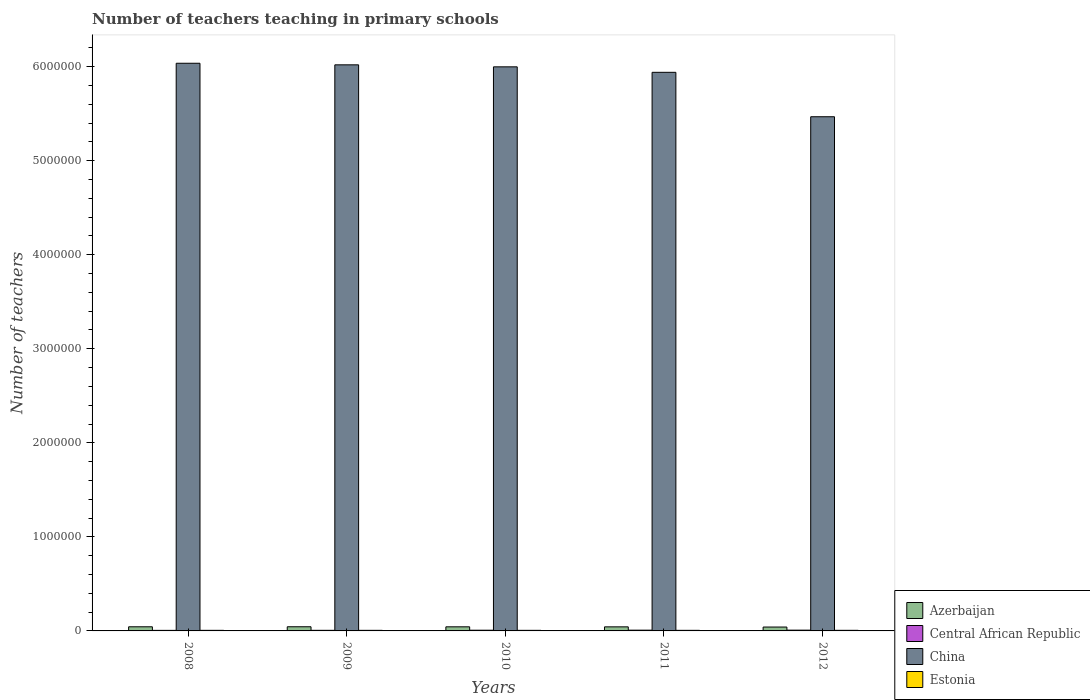How many different coloured bars are there?
Give a very brief answer. 4. How many groups of bars are there?
Ensure brevity in your answer.  5. Are the number of bars per tick equal to the number of legend labels?
Your answer should be compact. Yes. Are the number of bars on each tick of the X-axis equal?
Your answer should be very brief. Yes. How many bars are there on the 5th tick from the left?
Provide a succinct answer. 4. How many bars are there on the 5th tick from the right?
Offer a terse response. 4. In how many cases, is the number of bars for a given year not equal to the number of legend labels?
Your answer should be compact. 0. What is the number of teachers teaching in primary schools in Central African Republic in 2008?
Your response must be concise. 5827. Across all years, what is the maximum number of teachers teaching in primary schools in Azerbaijan?
Make the answer very short. 4.42e+04. Across all years, what is the minimum number of teachers teaching in primary schools in Central African Republic?
Your response must be concise. 5827. What is the total number of teachers teaching in primary schools in Central African Republic in the graph?
Offer a very short reply. 3.60e+04. What is the difference between the number of teachers teaching in primary schools in Estonia in 2009 and that in 2011?
Give a very brief answer. -17. What is the difference between the number of teachers teaching in primary schools in Central African Republic in 2010 and the number of teachers teaching in primary schools in China in 2012?
Provide a short and direct response. -5.46e+06. What is the average number of teachers teaching in primary schools in Azerbaijan per year?
Ensure brevity in your answer.  4.33e+04. In the year 2008, what is the difference between the number of teachers teaching in primary schools in Estonia and number of teachers teaching in primary schools in China?
Give a very brief answer. -6.03e+06. What is the ratio of the number of teachers teaching in primary schools in Central African Republic in 2009 to that in 2012?
Offer a very short reply. 0.78. Is the number of teachers teaching in primary schools in Azerbaijan in 2010 less than that in 2012?
Make the answer very short. No. What is the difference between the highest and the second highest number of teachers teaching in primary schools in Central African Republic?
Offer a very short reply. 293. What is the difference between the highest and the lowest number of teachers teaching in primary schools in China?
Your answer should be compact. 5.69e+05. In how many years, is the number of teachers teaching in primary schools in Estonia greater than the average number of teachers teaching in primary schools in Estonia taken over all years?
Offer a terse response. 1. Is the sum of the number of teachers teaching in primary schools in China in 2008 and 2009 greater than the maximum number of teachers teaching in primary schools in Central African Republic across all years?
Your answer should be very brief. Yes. What does the 4th bar from the left in 2009 represents?
Your response must be concise. Estonia. What does the 2nd bar from the right in 2010 represents?
Offer a very short reply. China. Is it the case that in every year, the sum of the number of teachers teaching in primary schools in Azerbaijan and number of teachers teaching in primary schools in Estonia is greater than the number of teachers teaching in primary schools in Central African Republic?
Ensure brevity in your answer.  Yes. How many bars are there?
Keep it short and to the point. 20. How many years are there in the graph?
Offer a very short reply. 5. Does the graph contain grids?
Give a very brief answer. No. Where does the legend appear in the graph?
Keep it short and to the point. Bottom right. How many legend labels are there?
Your answer should be very brief. 4. How are the legend labels stacked?
Keep it short and to the point. Vertical. What is the title of the graph?
Your answer should be very brief. Number of teachers teaching in primary schools. What is the label or title of the Y-axis?
Your answer should be compact. Number of teachers. What is the Number of teachers of Azerbaijan in 2008?
Your answer should be compact. 4.40e+04. What is the Number of teachers of Central African Republic in 2008?
Keep it short and to the point. 5827. What is the Number of teachers of China in 2008?
Make the answer very short. 6.04e+06. What is the Number of teachers of Estonia in 2008?
Keep it short and to the point. 6141. What is the Number of teachers in Azerbaijan in 2009?
Keep it short and to the point. 4.42e+04. What is the Number of teachers of Central African Republic in 2009?
Your answer should be compact. 6427. What is the Number of teachers in China in 2009?
Give a very brief answer. 6.02e+06. What is the Number of teachers of Estonia in 2009?
Your answer should be very brief. 6183. What is the Number of teachers in Azerbaijan in 2010?
Your answer should be compact. 4.36e+04. What is the Number of teachers in Central African Republic in 2010?
Give a very brief answer. 7553. What is the Number of teachers in China in 2010?
Make the answer very short. 6.00e+06. What is the Number of teachers of Estonia in 2010?
Provide a short and direct response. 6223. What is the Number of teachers in Azerbaijan in 2011?
Provide a succinct answer. 4.32e+04. What is the Number of teachers of Central African Republic in 2011?
Make the answer very short. 7974. What is the Number of teachers of China in 2011?
Your answer should be compact. 5.94e+06. What is the Number of teachers in Estonia in 2011?
Provide a succinct answer. 6200. What is the Number of teachers in Azerbaijan in 2012?
Ensure brevity in your answer.  4.12e+04. What is the Number of teachers in Central African Republic in 2012?
Make the answer very short. 8267. What is the Number of teachers in China in 2012?
Make the answer very short. 5.47e+06. What is the Number of teachers in Estonia in 2012?
Offer a terse response. 6431. Across all years, what is the maximum Number of teachers of Azerbaijan?
Give a very brief answer. 4.42e+04. Across all years, what is the maximum Number of teachers of Central African Republic?
Make the answer very short. 8267. Across all years, what is the maximum Number of teachers in China?
Give a very brief answer. 6.04e+06. Across all years, what is the maximum Number of teachers in Estonia?
Offer a very short reply. 6431. Across all years, what is the minimum Number of teachers in Azerbaijan?
Ensure brevity in your answer.  4.12e+04. Across all years, what is the minimum Number of teachers in Central African Republic?
Offer a terse response. 5827. Across all years, what is the minimum Number of teachers of China?
Give a very brief answer. 5.47e+06. Across all years, what is the minimum Number of teachers in Estonia?
Give a very brief answer. 6141. What is the total Number of teachers of Azerbaijan in the graph?
Give a very brief answer. 2.16e+05. What is the total Number of teachers of Central African Republic in the graph?
Make the answer very short. 3.60e+04. What is the total Number of teachers in China in the graph?
Your answer should be compact. 2.95e+07. What is the total Number of teachers in Estonia in the graph?
Make the answer very short. 3.12e+04. What is the difference between the Number of teachers of Azerbaijan in 2008 and that in 2009?
Your answer should be very brief. -261. What is the difference between the Number of teachers in Central African Republic in 2008 and that in 2009?
Ensure brevity in your answer.  -600. What is the difference between the Number of teachers of China in 2008 and that in 2009?
Provide a short and direct response. 1.67e+04. What is the difference between the Number of teachers of Estonia in 2008 and that in 2009?
Keep it short and to the point. -42. What is the difference between the Number of teachers in Azerbaijan in 2008 and that in 2010?
Provide a short and direct response. 361. What is the difference between the Number of teachers of Central African Republic in 2008 and that in 2010?
Give a very brief answer. -1726. What is the difference between the Number of teachers of China in 2008 and that in 2010?
Provide a short and direct response. 3.81e+04. What is the difference between the Number of teachers of Estonia in 2008 and that in 2010?
Keep it short and to the point. -82. What is the difference between the Number of teachers of Azerbaijan in 2008 and that in 2011?
Ensure brevity in your answer.  729. What is the difference between the Number of teachers in Central African Republic in 2008 and that in 2011?
Provide a short and direct response. -2147. What is the difference between the Number of teachers of China in 2008 and that in 2011?
Offer a very short reply. 9.64e+04. What is the difference between the Number of teachers of Estonia in 2008 and that in 2011?
Your answer should be very brief. -59. What is the difference between the Number of teachers of Azerbaijan in 2008 and that in 2012?
Provide a succinct answer. 2750. What is the difference between the Number of teachers in Central African Republic in 2008 and that in 2012?
Your answer should be compact. -2440. What is the difference between the Number of teachers in China in 2008 and that in 2012?
Your answer should be very brief. 5.69e+05. What is the difference between the Number of teachers of Estonia in 2008 and that in 2012?
Make the answer very short. -290. What is the difference between the Number of teachers of Azerbaijan in 2009 and that in 2010?
Ensure brevity in your answer.  622. What is the difference between the Number of teachers in Central African Republic in 2009 and that in 2010?
Provide a succinct answer. -1126. What is the difference between the Number of teachers of China in 2009 and that in 2010?
Offer a very short reply. 2.14e+04. What is the difference between the Number of teachers in Estonia in 2009 and that in 2010?
Provide a short and direct response. -40. What is the difference between the Number of teachers in Azerbaijan in 2009 and that in 2011?
Provide a short and direct response. 990. What is the difference between the Number of teachers in Central African Republic in 2009 and that in 2011?
Keep it short and to the point. -1547. What is the difference between the Number of teachers of China in 2009 and that in 2011?
Your response must be concise. 7.97e+04. What is the difference between the Number of teachers in Estonia in 2009 and that in 2011?
Provide a succinct answer. -17. What is the difference between the Number of teachers in Azerbaijan in 2009 and that in 2012?
Offer a terse response. 3011. What is the difference between the Number of teachers in Central African Republic in 2009 and that in 2012?
Offer a very short reply. -1840. What is the difference between the Number of teachers of China in 2009 and that in 2012?
Offer a very short reply. 5.52e+05. What is the difference between the Number of teachers of Estonia in 2009 and that in 2012?
Ensure brevity in your answer.  -248. What is the difference between the Number of teachers of Azerbaijan in 2010 and that in 2011?
Offer a very short reply. 368. What is the difference between the Number of teachers in Central African Republic in 2010 and that in 2011?
Ensure brevity in your answer.  -421. What is the difference between the Number of teachers of China in 2010 and that in 2011?
Give a very brief answer. 5.83e+04. What is the difference between the Number of teachers of Azerbaijan in 2010 and that in 2012?
Your response must be concise. 2389. What is the difference between the Number of teachers in Central African Republic in 2010 and that in 2012?
Provide a short and direct response. -714. What is the difference between the Number of teachers in China in 2010 and that in 2012?
Provide a succinct answer. 5.30e+05. What is the difference between the Number of teachers in Estonia in 2010 and that in 2012?
Your response must be concise. -208. What is the difference between the Number of teachers of Azerbaijan in 2011 and that in 2012?
Keep it short and to the point. 2021. What is the difference between the Number of teachers in Central African Republic in 2011 and that in 2012?
Provide a short and direct response. -293. What is the difference between the Number of teachers of China in 2011 and that in 2012?
Offer a terse response. 4.72e+05. What is the difference between the Number of teachers in Estonia in 2011 and that in 2012?
Make the answer very short. -231. What is the difference between the Number of teachers of Azerbaijan in 2008 and the Number of teachers of Central African Republic in 2009?
Your response must be concise. 3.75e+04. What is the difference between the Number of teachers in Azerbaijan in 2008 and the Number of teachers in China in 2009?
Your answer should be very brief. -5.97e+06. What is the difference between the Number of teachers of Azerbaijan in 2008 and the Number of teachers of Estonia in 2009?
Your answer should be very brief. 3.78e+04. What is the difference between the Number of teachers in Central African Republic in 2008 and the Number of teachers in China in 2009?
Ensure brevity in your answer.  -6.01e+06. What is the difference between the Number of teachers in Central African Republic in 2008 and the Number of teachers in Estonia in 2009?
Ensure brevity in your answer.  -356. What is the difference between the Number of teachers in China in 2008 and the Number of teachers in Estonia in 2009?
Provide a short and direct response. 6.03e+06. What is the difference between the Number of teachers of Azerbaijan in 2008 and the Number of teachers of Central African Republic in 2010?
Make the answer very short. 3.64e+04. What is the difference between the Number of teachers in Azerbaijan in 2008 and the Number of teachers in China in 2010?
Offer a terse response. -5.95e+06. What is the difference between the Number of teachers in Azerbaijan in 2008 and the Number of teachers in Estonia in 2010?
Offer a terse response. 3.77e+04. What is the difference between the Number of teachers in Central African Republic in 2008 and the Number of teachers in China in 2010?
Keep it short and to the point. -5.99e+06. What is the difference between the Number of teachers in Central African Republic in 2008 and the Number of teachers in Estonia in 2010?
Make the answer very short. -396. What is the difference between the Number of teachers of China in 2008 and the Number of teachers of Estonia in 2010?
Give a very brief answer. 6.03e+06. What is the difference between the Number of teachers of Azerbaijan in 2008 and the Number of teachers of Central African Republic in 2011?
Provide a short and direct response. 3.60e+04. What is the difference between the Number of teachers in Azerbaijan in 2008 and the Number of teachers in China in 2011?
Provide a short and direct response. -5.90e+06. What is the difference between the Number of teachers of Azerbaijan in 2008 and the Number of teachers of Estonia in 2011?
Your response must be concise. 3.78e+04. What is the difference between the Number of teachers in Central African Republic in 2008 and the Number of teachers in China in 2011?
Make the answer very short. -5.93e+06. What is the difference between the Number of teachers of Central African Republic in 2008 and the Number of teachers of Estonia in 2011?
Offer a terse response. -373. What is the difference between the Number of teachers in China in 2008 and the Number of teachers in Estonia in 2011?
Offer a terse response. 6.03e+06. What is the difference between the Number of teachers of Azerbaijan in 2008 and the Number of teachers of Central African Republic in 2012?
Keep it short and to the point. 3.57e+04. What is the difference between the Number of teachers of Azerbaijan in 2008 and the Number of teachers of China in 2012?
Keep it short and to the point. -5.42e+06. What is the difference between the Number of teachers of Azerbaijan in 2008 and the Number of teachers of Estonia in 2012?
Keep it short and to the point. 3.75e+04. What is the difference between the Number of teachers of Central African Republic in 2008 and the Number of teachers of China in 2012?
Offer a terse response. -5.46e+06. What is the difference between the Number of teachers in Central African Republic in 2008 and the Number of teachers in Estonia in 2012?
Provide a short and direct response. -604. What is the difference between the Number of teachers of China in 2008 and the Number of teachers of Estonia in 2012?
Your answer should be compact. 6.03e+06. What is the difference between the Number of teachers of Azerbaijan in 2009 and the Number of teachers of Central African Republic in 2010?
Your response must be concise. 3.67e+04. What is the difference between the Number of teachers in Azerbaijan in 2009 and the Number of teachers in China in 2010?
Provide a short and direct response. -5.95e+06. What is the difference between the Number of teachers in Azerbaijan in 2009 and the Number of teachers in Estonia in 2010?
Offer a very short reply. 3.80e+04. What is the difference between the Number of teachers in Central African Republic in 2009 and the Number of teachers in China in 2010?
Give a very brief answer. -5.99e+06. What is the difference between the Number of teachers in Central African Republic in 2009 and the Number of teachers in Estonia in 2010?
Your answer should be compact. 204. What is the difference between the Number of teachers in China in 2009 and the Number of teachers in Estonia in 2010?
Provide a short and direct response. 6.01e+06. What is the difference between the Number of teachers in Azerbaijan in 2009 and the Number of teachers in Central African Republic in 2011?
Give a very brief answer. 3.63e+04. What is the difference between the Number of teachers of Azerbaijan in 2009 and the Number of teachers of China in 2011?
Keep it short and to the point. -5.89e+06. What is the difference between the Number of teachers in Azerbaijan in 2009 and the Number of teachers in Estonia in 2011?
Provide a short and direct response. 3.80e+04. What is the difference between the Number of teachers in Central African Republic in 2009 and the Number of teachers in China in 2011?
Keep it short and to the point. -5.93e+06. What is the difference between the Number of teachers of Central African Republic in 2009 and the Number of teachers of Estonia in 2011?
Your response must be concise. 227. What is the difference between the Number of teachers of China in 2009 and the Number of teachers of Estonia in 2011?
Make the answer very short. 6.01e+06. What is the difference between the Number of teachers in Azerbaijan in 2009 and the Number of teachers in Central African Republic in 2012?
Give a very brief answer. 3.60e+04. What is the difference between the Number of teachers in Azerbaijan in 2009 and the Number of teachers in China in 2012?
Ensure brevity in your answer.  -5.42e+06. What is the difference between the Number of teachers in Azerbaijan in 2009 and the Number of teachers in Estonia in 2012?
Your response must be concise. 3.78e+04. What is the difference between the Number of teachers of Central African Republic in 2009 and the Number of teachers of China in 2012?
Make the answer very short. -5.46e+06. What is the difference between the Number of teachers of China in 2009 and the Number of teachers of Estonia in 2012?
Provide a short and direct response. 6.01e+06. What is the difference between the Number of teachers in Azerbaijan in 2010 and the Number of teachers in Central African Republic in 2011?
Your answer should be very brief. 3.56e+04. What is the difference between the Number of teachers in Azerbaijan in 2010 and the Number of teachers in China in 2011?
Keep it short and to the point. -5.90e+06. What is the difference between the Number of teachers of Azerbaijan in 2010 and the Number of teachers of Estonia in 2011?
Provide a succinct answer. 3.74e+04. What is the difference between the Number of teachers in Central African Republic in 2010 and the Number of teachers in China in 2011?
Your answer should be compact. -5.93e+06. What is the difference between the Number of teachers of Central African Republic in 2010 and the Number of teachers of Estonia in 2011?
Provide a succinct answer. 1353. What is the difference between the Number of teachers of China in 2010 and the Number of teachers of Estonia in 2011?
Keep it short and to the point. 5.99e+06. What is the difference between the Number of teachers in Azerbaijan in 2010 and the Number of teachers in Central African Republic in 2012?
Provide a short and direct response. 3.53e+04. What is the difference between the Number of teachers of Azerbaijan in 2010 and the Number of teachers of China in 2012?
Your answer should be compact. -5.42e+06. What is the difference between the Number of teachers of Azerbaijan in 2010 and the Number of teachers of Estonia in 2012?
Offer a very short reply. 3.72e+04. What is the difference between the Number of teachers of Central African Republic in 2010 and the Number of teachers of China in 2012?
Offer a very short reply. -5.46e+06. What is the difference between the Number of teachers of Central African Republic in 2010 and the Number of teachers of Estonia in 2012?
Provide a short and direct response. 1122. What is the difference between the Number of teachers in China in 2010 and the Number of teachers in Estonia in 2012?
Provide a short and direct response. 5.99e+06. What is the difference between the Number of teachers of Azerbaijan in 2011 and the Number of teachers of Central African Republic in 2012?
Offer a terse response. 3.50e+04. What is the difference between the Number of teachers in Azerbaijan in 2011 and the Number of teachers in China in 2012?
Offer a very short reply. -5.42e+06. What is the difference between the Number of teachers in Azerbaijan in 2011 and the Number of teachers in Estonia in 2012?
Ensure brevity in your answer.  3.68e+04. What is the difference between the Number of teachers in Central African Republic in 2011 and the Number of teachers in China in 2012?
Your answer should be compact. -5.46e+06. What is the difference between the Number of teachers of Central African Republic in 2011 and the Number of teachers of Estonia in 2012?
Provide a short and direct response. 1543. What is the difference between the Number of teachers of China in 2011 and the Number of teachers of Estonia in 2012?
Ensure brevity in your answer.  5.93e+06. What is the average Number of teachers of Azerbaijan per year?
Provide a short and direct response. 4.33e+04. What is the average Number of teachers in Central African Republic per year?
Make the answer very short. 7209.6. What is the average Number of teachers in China per year?
Your response must be concise. 5.89e+06. What is the average Number of teachers in Estonia per year?
Provide a succinct answer. 6235.6. In the year 2008, what is the difference between the Number of teachers of Azerbaijan and Number of teachers of Central African Republic?
Offer a terse response. 3.81e+04. In the year 2008, what is the difference between the Number of teachers in Azerbaijan and Number of teachers in China?
Offer a terse response. -5.99e+06. In the year 2008, what is the difference between the Number of teachers of Azerbaijan and Number of teachers of Estonia?
Provide a short and direct response. 3.78e+04. In the year 2008, what is the difference between the Number of teachers in Central African Republic and Number of teachers in China?
Make the answer very short. -6.03e+06. In the year 2008, what is the difference between the Number of teachers of Central African Republic and Number of teachers of Estonia?
Offer a terse response. -314. In the year 2008, what is the difference between the Number of teachers in China and Number of teachers in Estonia?
Provide a succinct answer. 6.03e+06. In the year 2009, what is the difference between the Number of teachers in Azerbaijan and Number of teachers in Central African Republic?
Offer a very short reply. 3.78e+04. In the year 2009, what is the difference between the Number of teachers in Azerbaijan and Number of teachers in China?
Ensure brevity in your answer.  -5.97e+06. In the year 2009, what is the difference between the Number of teachers in Azerbaijan and Number of teachers in Estonia?
Provide a short and direct response. 3.80e+04. In the year 2009, what is the difference between the Number of teachers of Central African Republic and Number of teachers of China?
Give a very brief answer. -6.01e+06. In the year 2009, what is the difference between the Number of teachers of Central African Republic and Number of teachers of Estonia?
Offer a very short reply. 244. In the year 2009, what is the difference between the Number of teachers in China and Number of teachers in Estonia?
Your answer should be very brief. 6.01e+06. In the year 2010, what is the difference between the Number of teachers in Azerbaijan and Number of teachers in Central African Republic?
Give a very brief answer. 3.61e+04. In the year 2010, what is the difference between the Number of teachers in Azerbaijan and Number of teachers in China?
Give a very brief answer. -5.95e+06. In the year 2010, what is the difference between the Number of teachers in Azerbaijan and Number of teachers in Estonia?
Your answer should be very brief. 3.74e+04. In the year 2010, what is the difference between the Number of teachers in Central African Republic and Number of teachers in China?
Provide a succinct answer. -5.99e+06. In the year 2010, what is the difference between the Number of teachers in Central African Republic and Number of teachers in Estonia?
Give a very brief answer. 1330. In the year 2010, what is the difference between the Number of teachers in China and Number of teachers in Estonia?
Provide a short and direct response. 5.99e+06. In the year 2011, what is the difference between the Number of teachers in Azerbaijan and Number of teachers in Central African Republic?
Offer a terse response. 3.53e+04. In the year 2011, what is the difference between the Number of teachers of Azerbaijan and Number of teachers of China?
Provide a succinct answer. -5.90e+06. In the year 2011, what is the difference between the Number of teachers in Azerbaijan and Number of teachers in Estonia?
Keep it short and to the point. 3.70e+04. In the year 2011, what is the difference between the Number of teachers in Central African Republic and Number of teachers in China?
Provide a short and direct response. -5.93e+06. In the year 2011, what is the difference between the Number of teachers in Central African Republic and Number of teachers in Estonia?
Make the answer very short. 1774. In the year 2011, what is the difference between the Number of teachers of China and Number of teachers of Estonia?
Your answer should be compact. 5.93e+06. In the year 2012, what is the difference between the Number of teachers of Azerbaijan and Number of teachers of Central African Republic?
Provide a short and direct response. 3.30e+04. In the year 2012, what is the difference between the Number of teachers in Azerbaijan and Number of teachers in China?
Your response must be concise. -5.43e+06. In the year 2012, what is the difference between the Number of teachers of Azerbaijan and Number of teachers of Estonia?
Your answer should be very brief. 3.48e+04. In the year 2012, what is the difference between the Number of teachers in Central African Republic and Number of teachers in China?
Your answer should be very brief. -5.46e+06. In the year 2012, what is the difference between the Number of teachers in Central African Republic and Number of teachers in Estonia?
Provide a succinct answer. 1836. In the year 2012, what is the difference between the Number of teachers in China and Number of teachers in Estonia?
Make the answer very short. 5.46e+06. What is the ratio of the Number of teachers in Azerbaijan in 2008 to that in 2009?
Offer a very short reply. 0.99. What is the ratio of the Number of teachers in Central African Republic in 2008 to that in 2009?
Your answer should be compact. 0.91. What is the ratio of the Number of teachers in China in 2008 to that in 2009?
Your response must be concise. 1. What is the ratio of the Number of teachers of Azerbaijan in 2008 to that in 2010?
Offer a terse response. 1.01. What is the ratio of the Number of teachers of Central African Republic in 2008 to that in 2010?
Keep it short and to the point. 0.77. What is the ratio of the Number of teachers of China in 2008 to that in 2010?
Ensure brevity in your answer.  1.01. What is the ratio of the Number of teachers in Estonia in 2008 to that in 2010?
Offer a terse response. 0.99. What is the ratio of the Number of teachers in Azerbaijan in 2008 to that in 2011?
Your answer should be very brief. 1.02. What is the ratio of the Number of teachers of Central African Republic in 2008 to that in 2011?
Make the answer very short. 0.73. What is the ratio of the Number of teachers of China in 2008 to that in 2011?
Provide a short and direct response. 1.02. What is the ratio of the Number of teachers of Estonia in 2008 to that in 2011?
Offer a terse response. 0.99. What is the ratio of the Number of teachers of Azerbaijan in 2008 to that in 2012?
Keep it short and to the point. 1.07. What is the ratio of the Number of teachers in Central African Republic in 2008 to that in 2012?
Provide a succinct answer. 0.7. What is the ratio of the Number of teachers in China in 2008 to that in 2012?
Your answer should be compact. 1.1. What is the ratio of the Number of teachers of Estonia in 2008 to that in 2012?
Provide a short and direct response. 0.95. What is the ratio of the Number of teachers of Azerbaijan in 2009 to that in 2010?
Provide a short and direct response. 1.01. What is the ratio of the Number of teachers of Central African Republic in 2009 to that in 2010?
Give a very brief answer. 0.85. What is the ratio of the Number of teachers in Estonia in 2009 to that in 2010?
Make the answer very short. 0.99. What is the ratio of the Number of teachers of Azerbaijan in 2009 to that in 2011?
Your response must be concise. 1.02. What is the ratio of the Number of teachers of Central African Republic in 2009 to that in 2011?
Ensure brevity in your answer.  0.81. What is the ratio of the Number of teachers of China in 2009 to that in 2011?
Offer a terse response. 1.01. What is the ratio of the Number of teachers in Estonia in 2009 to that in 2011?
Your response must be concise. 1. What is the ratio of the Number of teachers in Azerbaijan in 2009 to that in 2012?
Your response must be concise. 1.07. What is the ratio of the Number of teachers of Central African Republic in 2009 to that in 2012?
Your answer should be compact. 0.78. What is the ratio of the Number of teachers of China in 2009 to that in 2012?
Your response must be concise. 1.1. What is the ratio of the Number of teachers in Estonia in 2009 to that in 2012?
Keep it short and to the point. 0.96. What is the ratio of the Number of teachers of Azerbaijan in 2010 to that in 2011?
Provide a short and direct response. 1.01. What is the ratio of the Number of teachers of Central African Republic in 2010 to that in 2011?
Provide a succinct answer. 0.95. What is the ratio of the Number of teachers of China in 2010 to that in 2011?
Provide a short and direct response. 1.01. What is the ratio of the Number of teachers of Azerbaijan in 2010 to that in 2012?
Make the answer very short. 1.06. What is the ratio of the Number of teachers of Central African Republic in 2010 to that in 2012?
Make the answer very short. 0.91. What is the ratio of the Number of teachers in China in 2010 to that in 2012?
Provide a short and direct response. 1.1. What is the ratio of the Number of teachers in Estonia in 2010 to that in 2012?
Offer a terse response. 0.97. What is the ratio of the Number of teachers of Azerbaijan in 2011 to that in 2012?
Ensure brevity in your answer.  1.05. What is the ratio of the Number of teachers in Central African Republic in 2011 to that in 2012?
Give a very brief answer. 0.96. What is the ratio of the Number of teachers in China in 2011 to that in 2012?
Give a very brief answer. 1.09. What is the ratio of the Number of teachers of Estonia in 2011 to that in 2012?
Ensure brevity in your answer.  0.96. What is the difference between the highest and the second highest Number of teachers in Azerbaijan?
Provide a succinct answer. 261. What is the difference between the highest and the second highest Number of teachers in Central African Republic?
Keep it short and to the point. 293. What is the difference between the highest and the second highest Number of teachers of China?
Ensure brevity in your answer.  1.67e+04. What is the difference between the highest and the second highest Number of teachers of Estonia?
Offer a terse response. 208. What is the difference between the highest and the lowest Number of teachers in Azerbaijan?
Give a very brief answer. 3011. What is the difference between the highest and the lowest Number of teachers in Central African Republic?
Make the answer very short. 2440. What is the difference between the highest and the lowest Number of teachers in China?
Provide a short and direct response. 5.69e+05. What is the difference between the highest and the lowest Number of teachers of Estonia?
Ensure brevity in your answer.  290. 